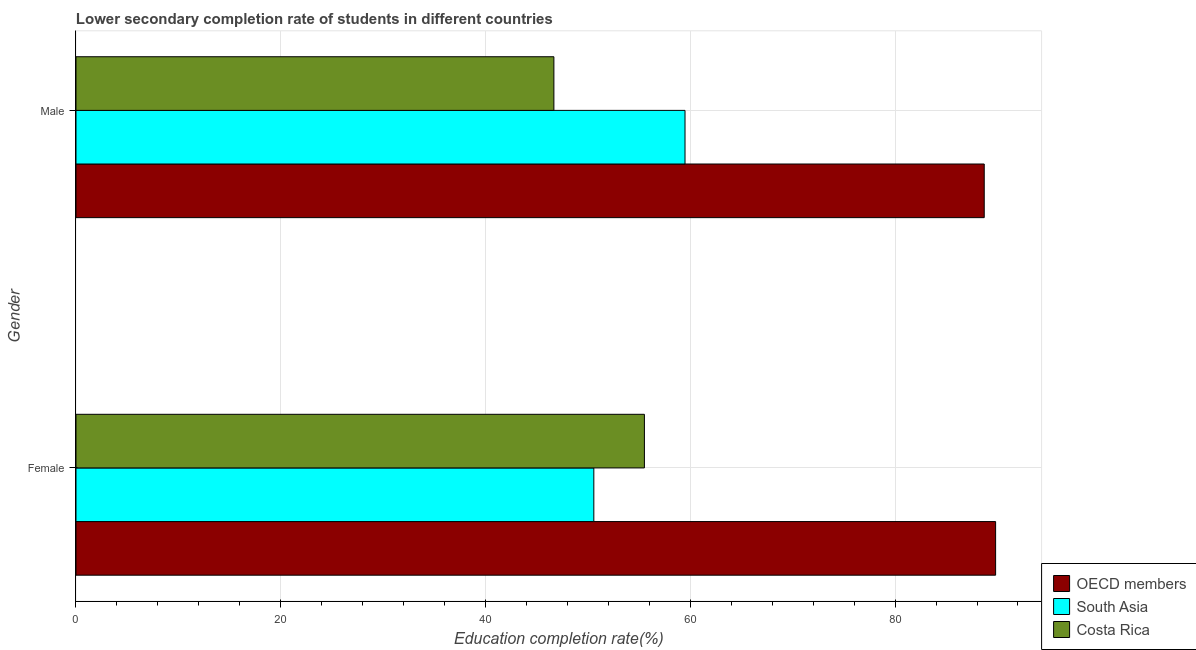How many different coloured bars are there?
Provide a short and direct response. 3. Are the number of bars on each tick of the Y-axis equal?
Your answer should be compact. Yes. What is the label of the 2nd group of bars from the top?
Your answer should be compact. Female. What is the education completion rate of female students in Costa Rica?
Offer a terse response. 55.52. Across all countries, what is the maximum education completion rate of male students?
Provide a short and direct response. 88.71. Across all countries, what is the minimum education completion rate of male students?
Ensure brevity in your answer.  46.68. What is the total education completion rate of male students in the graph?
Ensure brevity in your answer.  194.87. What is the difference between the education completion rate of male students in Costa Rica and that in South Asia?
Your answer should be very brief. -12.81. What is the difference between the education completion rate of female students in South Asia and the education completion rate of male students in OECD members?
Give a very brief answer. -38.13. What is the average education completion rate of female students per country?
Keep it short and to the point. 65.3. What is the difference between the education completion rate of male students and education completion rate of female students in South Asia?
Provide a short and direct response. 8.91. In how many countries, is the education completion rate of male students greater than 8 %?
Your response must be concise. 3. What is the ratio of the education completion rate of female students in Costa Rica to that in OECD members?
Offer a terse response. 0.62. Is the education completion rate of female students in South Asia less than that in OECD members?
Offer a terse response. Yes. What does the 2nd bar from the top in Male represents?
Give a very brief answer. South Asia. What does the 2nd bar from the bottom in Female represents?
Ensure brevity in your answer.  South Asia. Are all the bars in the graph horizontal?
Your response must be concise. Yes. What is the difference between two consecutive major ticks on the X-axis?
Give a very brief answer. 20. Are the values on the major ticks of X-axis written in scientific E-notation?
Your answer should be compact. No. Does the graph contain any zero values?
Provide a short and direct response. No. Does the graph contain grids?
Your answer should be compact. Yes. Where does the legend appear in the graph?
Offer a very short reply. Bottom right. What is the title of the graph?
Make the answer very short. Lower secondary completion rate of students in different countries. What is the label or title of the X-axis?
Offer a very short reply. Education completion rate(%). What is the label or title of the Y-axis?
Your answer should be compact. Gender. What is the Education completion rate(%) in OECD members in Female?
Give a very brief answer. 89.82. What is the Education completion rate(%) of South Asia in Female?
Provide a succinct answer. 50.58. What is the Education completion rate(%) of Costa Rica in Female?
Your response must be concise. 55.52. What is the Education completion rate(%) of OECD members in Male?
Your answer should be compact. 88.71. What is the Education completion rate(%) in South Asia in Male?
Provide a short and direct response. 59.48. What is the Education completion rate(%) of Costa Rica in Male?
Give a very brief answer. 46.68. Across all Gender, what is the maximum Education completion rate(%) in OECD members?
Make the answer very short. 89.82. Across all Gender, what is the maximum Education completion rate(%) in South Asia?
Keep it short and to the point. 59.48. Across all Gender, what is the maximum Education completion rate(%) of Costa Rica?
Your response must be concise. 55.52. Across all Gender, what is the minimum Education completion rate(%) of OECD members?
Keep it short and to the point. 88.71. Across all Gender, what is the minimum Education completion rate(%) of South Asia?
Your answer should be very brief. 50.58. Across all Gender, what is the minimum Education completion rate(%) of Costa Rica?
Offer a very short reply. 46.68. What is the total Education completion rate(%) of OECD members in the graph?
Your response must be concise. 178.52. What is the total Education completion rate(%) in South Asia in the graph?
Your answer should be compact. 110.06. What is the total Education completion rate(%) of Costa Rica in the graph?
Provide a short and direct response. 102.19. What is the difference between the Education completion rate(%) in OECD members in Female and that in Male?
Offer a very short reply. 1.11. What is the difference between the Education completion rate(%) in South Asia in Female and that in Male?
Your answer should be very brief. -8.91. What is the difference between the Education completion rate(%) in Costa Rica in Female and that in Male?
Your response must be concise. 8.84. What is the difference between the Education completion rate(%) in OECD members in Female and the Education completion rate(%) in South Asia in Male?
Make the answer very short. 30.33. What is the difference between the Education completion rate(%) of OECD members in Female and the Education completion rate(%) of Costa Rica in Male?
Offer a terse response. 43.14. What is the difference between the Education completion rate(%) in South Asia in Female and the Education completion rate(%) in Costa Rica in Male?
Give a very brief answer. 3.9. What is the average Education completion rate(%) of OECD members per Gender?
Keep it short and to the point. 89.26. What is the average Education completion rate(%) in South Asia per Gender?
Keep it short and to the point. 55.03. What is the average Education completion rate(%) of Costa Rica per Gender?
Make the answer very short. 51.1. What is the difference between the Education completion rate(%) of OECD members and Education completion rate(%) of South Asia in Female?
Make the answer very short. 39.24. What is the difference between the Education completion rate(%) of OECD members and Education completion rate(%) of Costa Rica in Female?
Your answer should be very brief. 34.3. What is the difference between the Education completion rate(%) in South Asia and Education completion rate(%) in Costa Rica in Female?
Provide a short and direct response. -4.94. What is the difference between the Education completion rate(%) in OECD members and Education completion rate(%) in South Asia in Male?
Give a very brief answer. 29.22. What is the difference between the Education completion rate(%) in OECD members and Education completion rate(%) in Costa Rica in Male?
Ensure brevity in your answer.  42.03. What is the difference between the Education completion rate(%) of South Asia and Education completion rate(%) of Costa Rica in Male?
Offer a very short reply. 12.81. What is the ratio of the Education completion rate(%) of OECD members in Female to that in Male?
Make the answer very short. 1.01. What is the ratio of the Education completion rate(%) in South Asia in Female to that in Male?
Your response must be concise. 0.85. What is the ratio of the Education completion rate(%) in Costa Rica in Female to that in Male?
Offer a terse response. 1.19. What is the difference between the highest and the second highest Education completion rate(%) of OECD members?
Your answer should be compact. 1.11. What is the difference between the highest and the second highest Education completion rate(%) in South Asia?
Keep it short and to the point. 8.91. What is the difference between the highest and the second highest Education completion rate(%) of Costa Rica?
Offer a very short reply. 8.84. What is the difference between the highest and the lowest Education completion rate(%) of OECD members?
Your answer should be compact. 1.11. What is the difference between the highest and the lowest Education completion rate(%) in South Asia?
Ensure brevity in your answer.  8.91. What is the difference between the highest and the lowest Education completion rate(%) in Costa Rica?
Offer a very short reply. 8.84. 